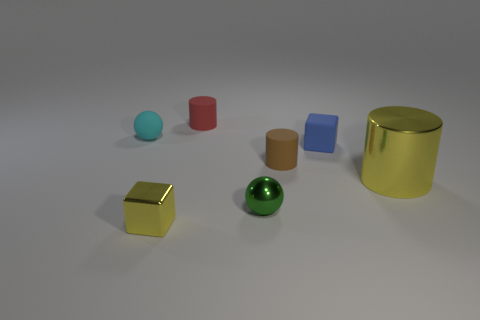There is another brown thing that is the same shape as the large thing; what is its size?
Make the answer very short. Small. There is a small shiny cube; does it have the same color as the small sphere behind the yellow metal cylinder?
Give a very brief answer. No. How many other objects are the same size as the green shiny ball?
Offer a terse response. 5. There is a object that is in front of the ball to the right of the yellow shiny object left of the big metal thing; what shape is it?
Ensure brevity in your answer.  Cube. There is a green shiny thing; is its size the same as the yellow metallic object that is to the left of the yellow cylinder?
Your response must be concise. Yes. There is a tiny matte object that is both left of the blue thing and in front of the cyan thing; what is its color?
Ensure brevity in your answer.  Brown. What number of other objects are there of the same shape as the tiny brown rubber thing?
Give a very brief answer. 2. Is the color of the cylinder on the left side of the green metallic thing the same as the small sphere in front of the tiny cyan rubber object?
Offer a terse response. No. There is a cylinder that is behind the cyan matte ball; is it the same size as the cube that is on the right side of the tiny green ball?
Your answer should be compact. Yes. Is there any other thing that has the same material as the small brown object?
Provide a short and direct response. Yes. 